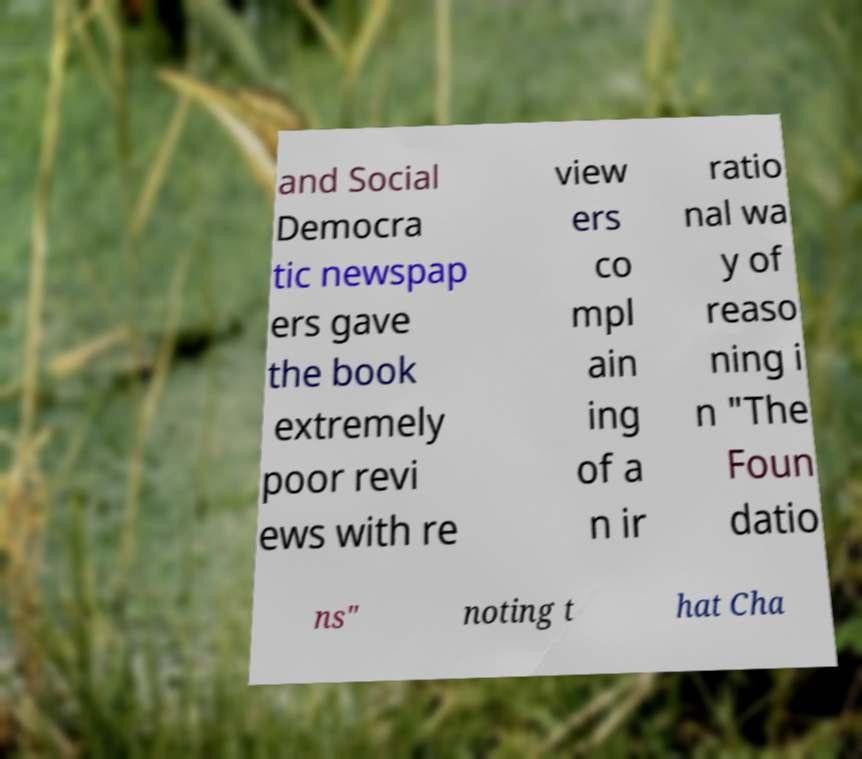Please identify and transcribe the text found in this image. and Social Democra tic newspap ers gave the book extremely poor revi ews with re view ers co mpl ain ing of a n ir ratio nal wa y of reaso ning i n "The Foun datio ns" noting t hat Cha 